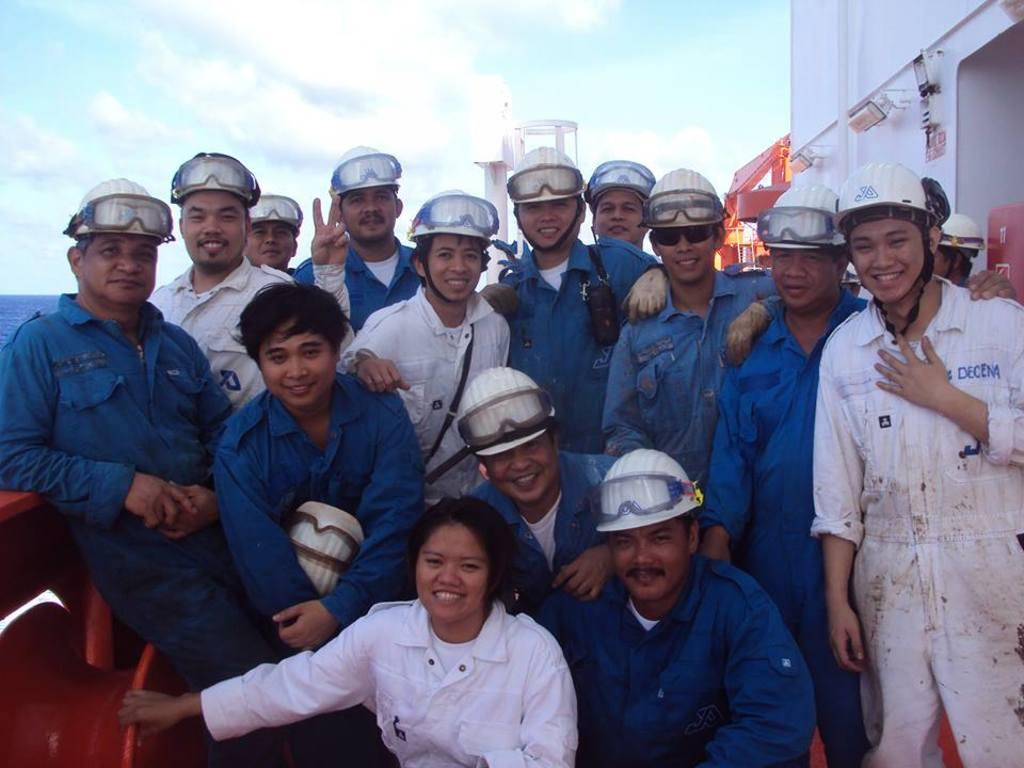Who or what can be seen in the front of the image? There are people in the front of the image. What are the people wearing on their heads? The people are wearing helmets. What else are the people wearing in the image? The people are also wearing goggles. Can you describe the object in the front of the image? There is an object in the front of the image, but its description is not provided in the facts. What can be seen in the background of the image? In the background of the image, there is water, a cloudy sky, a wall, lights, and other objects. What type of coal is being used by the people in the image? There is no mention of coal in the image or the provided facts. What kind of substance is being worn by the people in the image? The people are wearing helmets and goggles, not a substance. Are any of the people wearing skirts in the image? The provided facts do not mention any skirts being worn by the people in the image. 